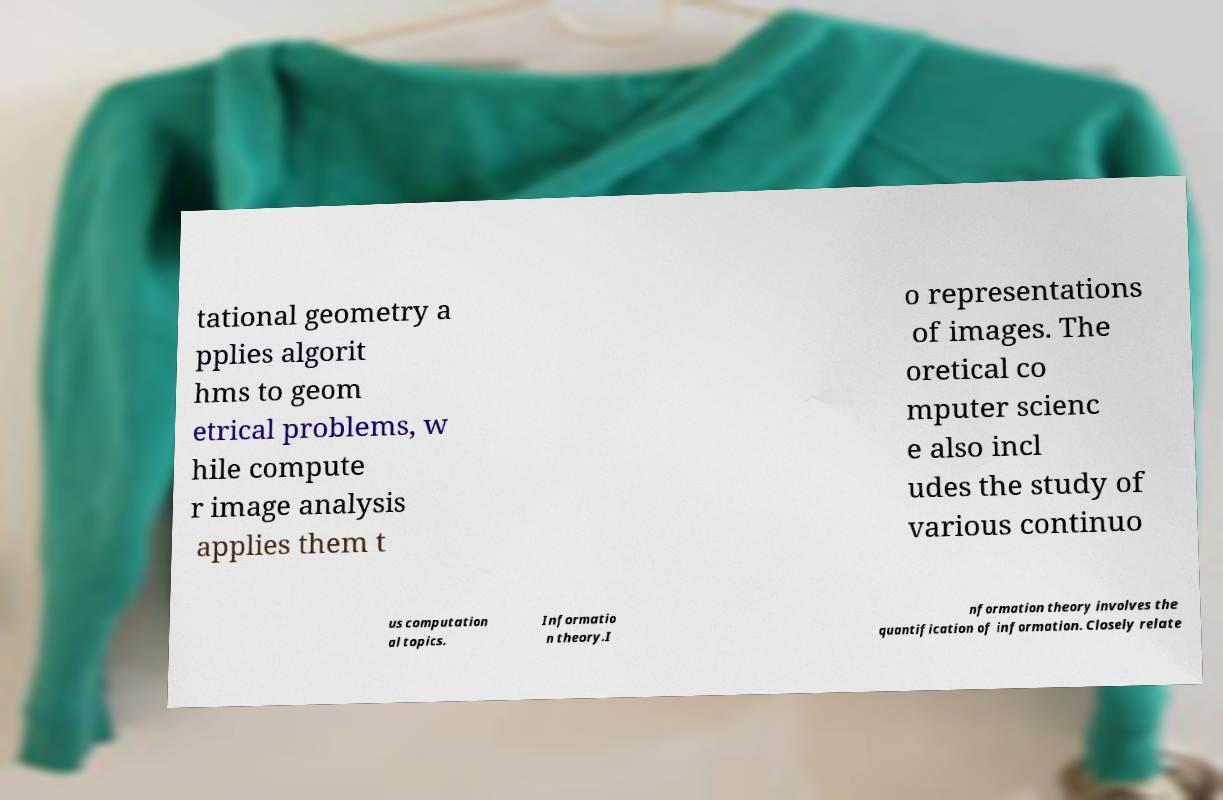There's text embedded in this image that I need extracted. Can you transcribe it verbatim? tational geometry a pplies algorit hms to geom etrical problems, w hile compute r image analysis applies them t o representations of images. The oretical co mputer scienc e also incl udes the study of various continuo us computation al topics. Informatio n theory.I nformation theory involves the quantification of information. Closely relate 